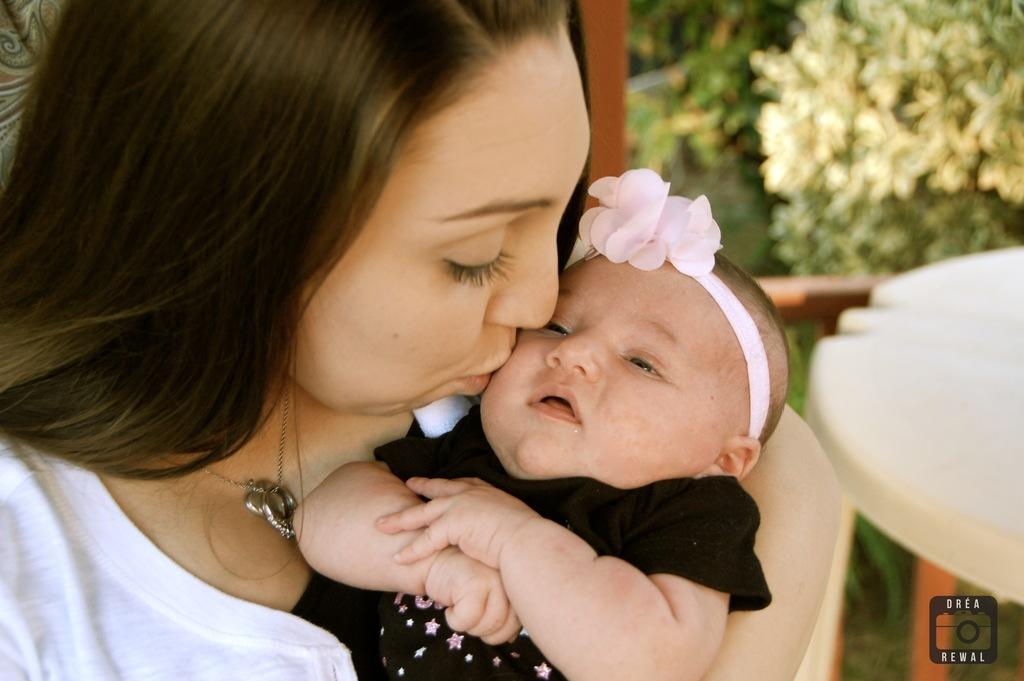How many people are present in the image? There are two persons in the image. What can be seen in the background of the image? There are many plants in the image. What type of furniture is visible in the image? There is a table in the image. What type of window treatment is present in the image? There is a curtain in the image. What type of animal can be seen interacting with the plants in the image? There is no animal present in the image; it only features two persons and many plants. How does the sleet affect the visibility of the table in the image? There is no mention of sleet in the image, and therefore it does not affect the visibility of the table. 